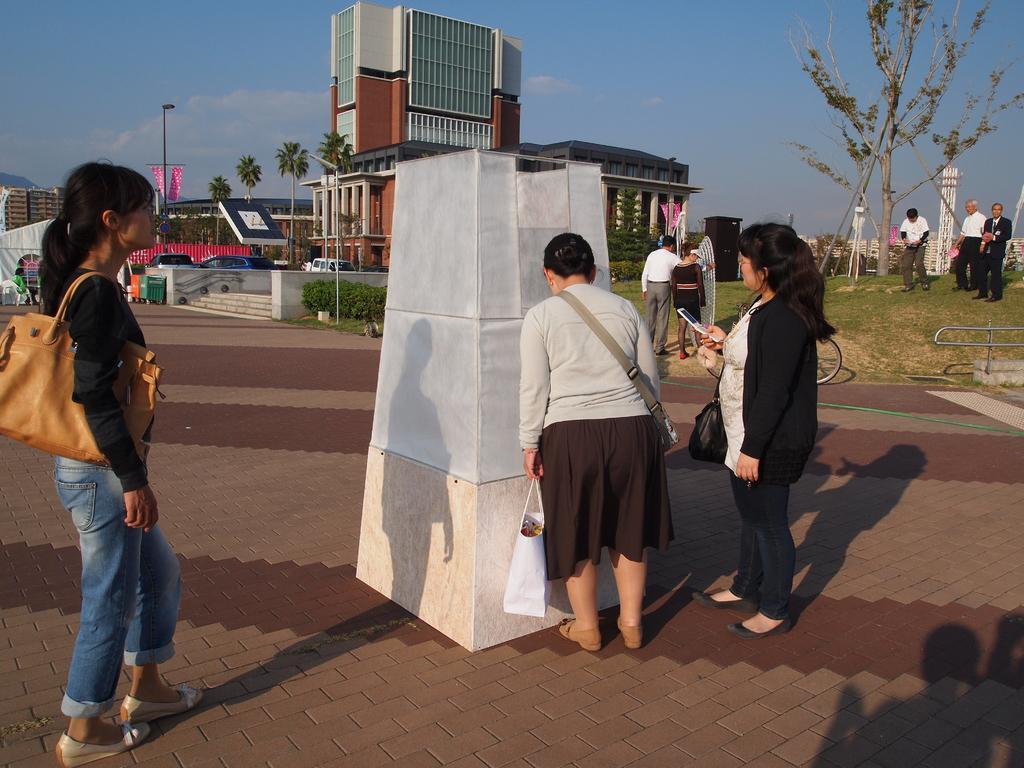Describe this image in one or two sentences. In this picture we can see three women standing in the front. In the middle there is a small stone pillar. In the background there is a brown and white color building and some coconut trees. On the top there is a sky. 